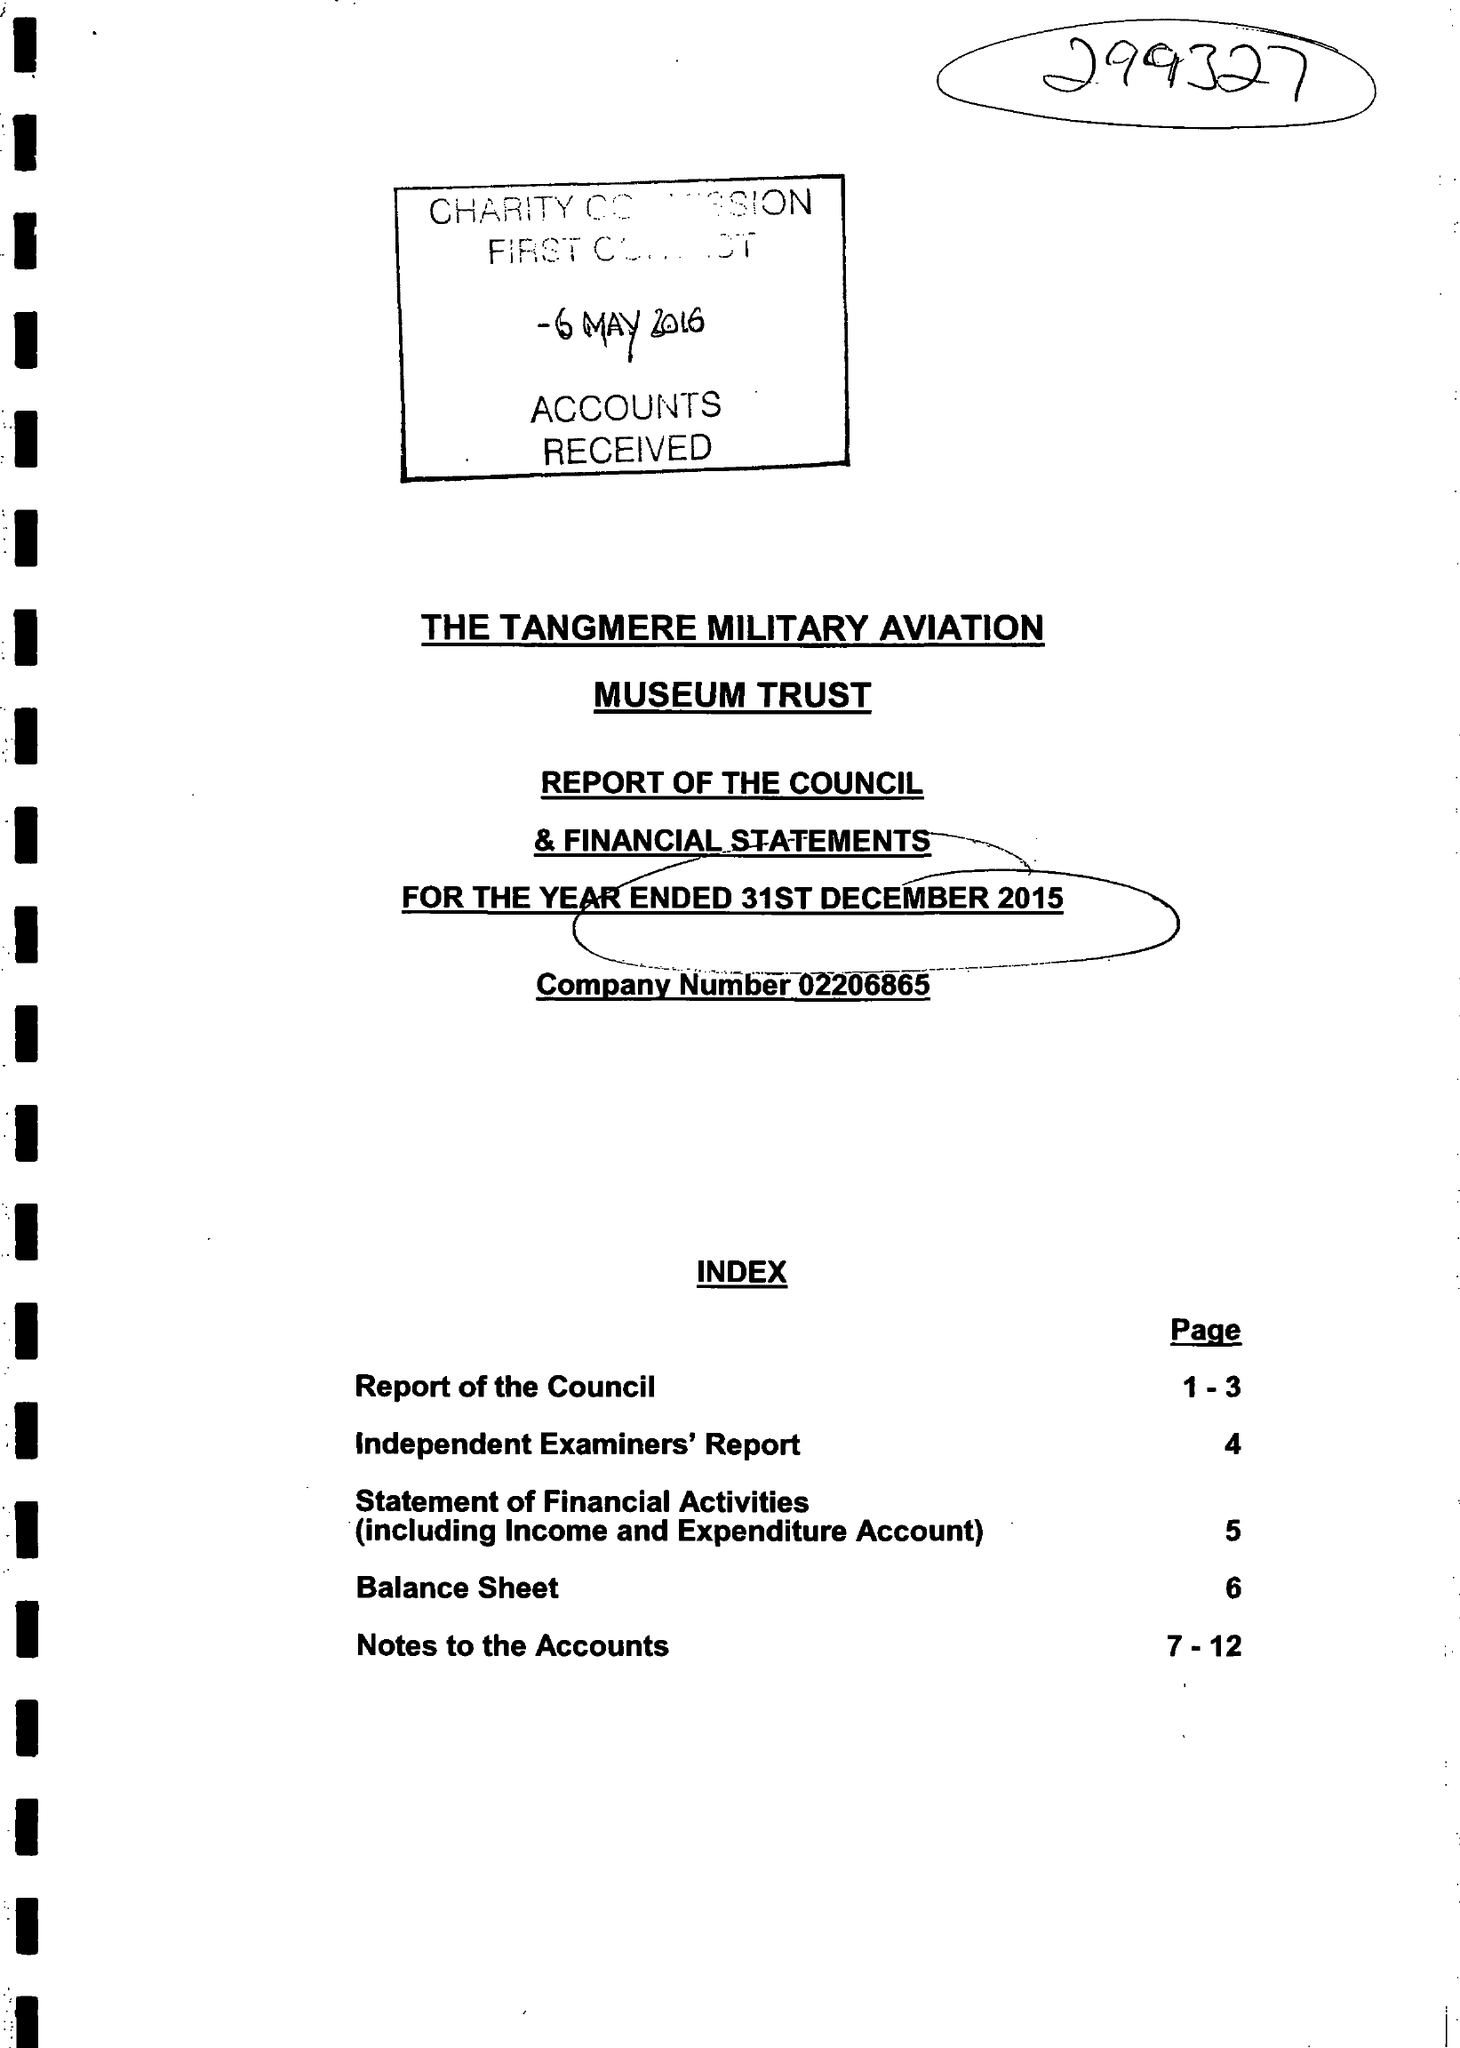What is the value for the income_annually_in_british_pounds?
Answer the question using a single word or phrase. 234504.00 